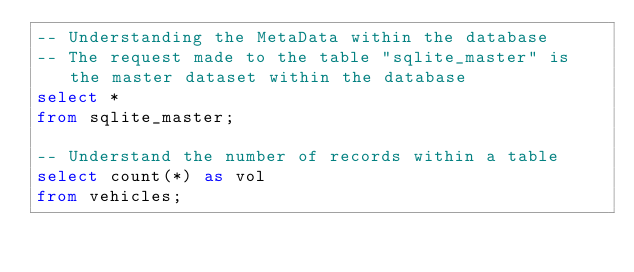<code> <loc_0><loc_0><loc_500><loc_500><_SQL_>-- Understanding the MetaData within the database
-- The request made to the table "sqlite_master" is the master dataset within the database
select *
from sqlite_master;

-- Understand the number of records within a table
select count(*) as vol
from vehicles;

</code> 